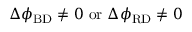Convert formula to latex. <formula><loc_0><loc_0><loc_500><loc_500>\Delta \phi _ { B D } \neq 0 \ o r \ \Delta \phi _ { R D } \neq 0</formula> 